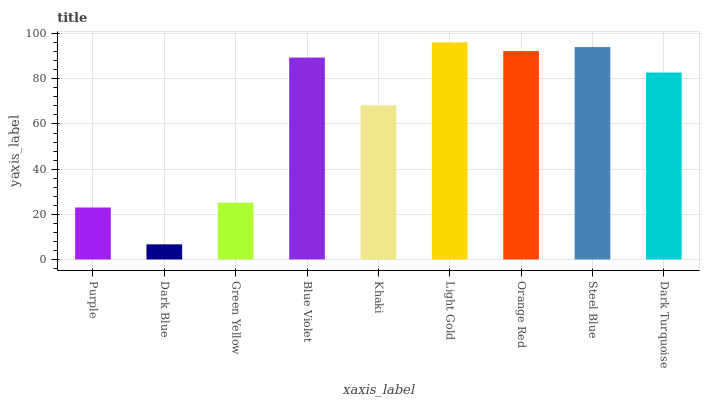Is Dark Blue the minimum?
Answer yes or no. Yes. Is Light Gold the maximum?
Answer yes or no. Yes. Is Green Yellow the minimum?
Answer yes or no. No. Is Green Yellow the maximum?
Answer yes or no. No. Is Green Yellow greater than Dark Blue?
Answer yes or no. Yes. Is Dark Blue less than Green Yellow?
Answer yes or no. Yes. Is Dark Blue greater than Green Yellow?
Answer yes or no. No. Is Green Yellow less than Dark Blue?
Answer yes or no. No. Is Dark Turquoise the high median?
Answer yes or no. Yes. Is Dark Turquoise the low median?
Answer yes or no. Yes. Is Light Gold the high median?
Answer yes or no. No. Is Dark Blue the low median?
Answer yes or no. No. 